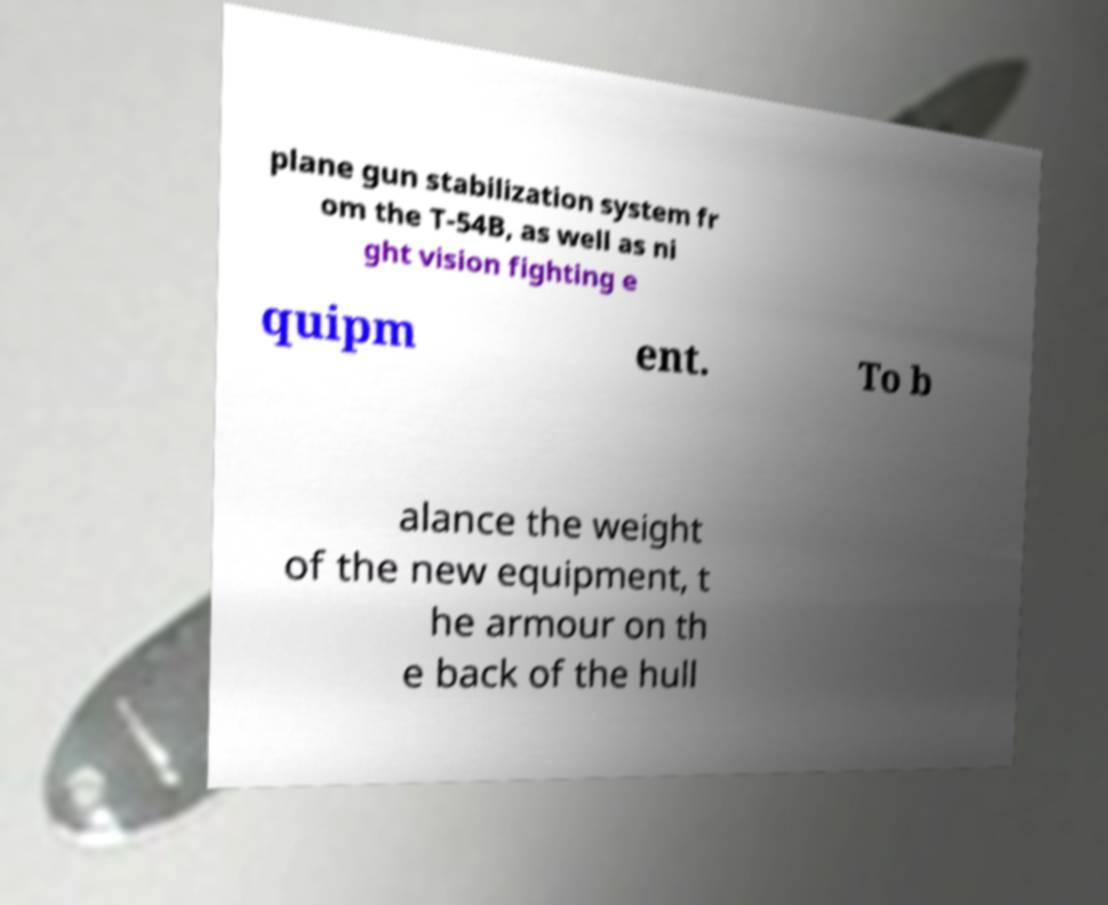Can you accurately transcribe the text from the provided image for me? plane gun stabilization system fr om the T-54B, as well as ni ght vision fighting e quipm ent. To b alance the weight of the new equipment, t he armour on th e back of the hull 